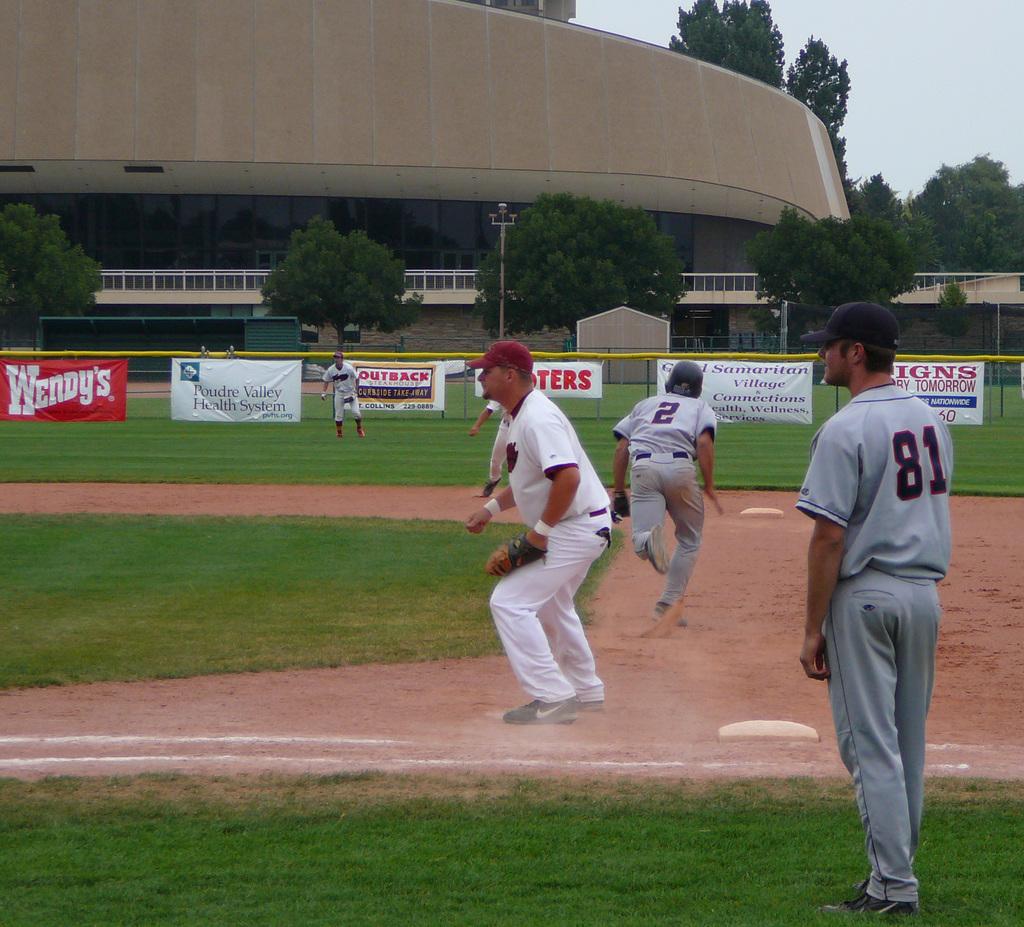What is the number of the runner?
Provide a short and direct response. 2. What is being advertised on the big red sign?
Ensure brevity in your answer.  Wendy's. 